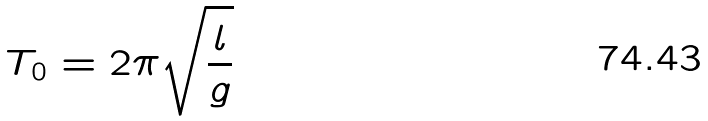<formula> <loc_0><loc_0><loc_500><loc_500>T _ { 0 } = 2 \pi \sqrt { \frac { l } { g } }</formula> 